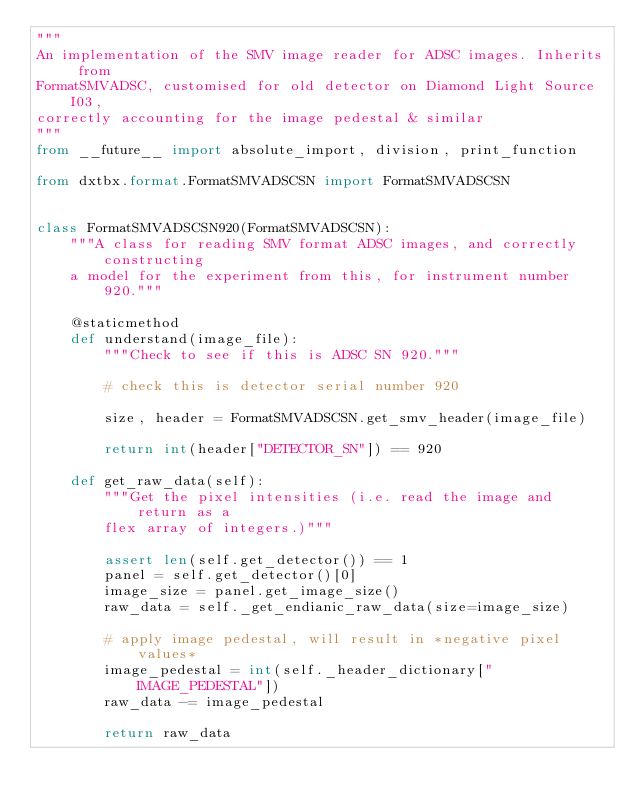Convert code to text. <code><loc_0><loc_0><loc_500><loc_500><_Python_>"""
An implementation of the SMV image reader for ADSC images. Inherits from
FormatSMVADSC, customised for old detector on Diamond Light Source I03,
correctly accounting for the image pedestal & similar
"""
from __future__ import absolute_import, division, print_function

from dxtbx.format.FormatSMVADSCSN import FormatSMVADSCSN


class FormatSMVADSCSN920(FormatSMVADSCSN):
    """A class for reading SMV format ADSC images, and correctly constructing
    a model for the experiment from this, for instrument number 920."""

    @staticmethod
    def understand(image_file):
        """Check to see if this is ADSC SN 920."""

        # check this is detector serial number 920

        size, header = FormatSMVADSCSN.get_smv_header(image_file)

        return int(header["DETECTOR_SN"]) == 920

    def get_raw_data(self):
        """Get the pixel intensities (i.e. read the image and return as a
        flex array of integers.)"""

        assert len(self.get_detector()) == 1
        panel = self.get_detector()[0]
        image_size = panel.get_image_size()
        raw_data = self._get_endianic_raw_data(size=image_size)

        # apply image pedestal, will result in *negative pixel values*
        image_pedestal = int(self._header_dictionary["IMAGE_PEDESTAL"])
        raw_data -= image_pedestal

        return raw_data
</code> 